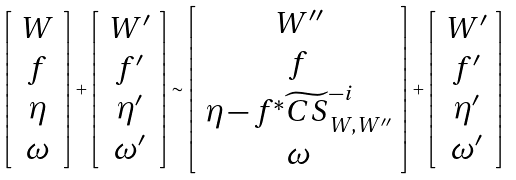Convert formula to latex. <formula><loc_0><loc_0><loc_500><loc_500>\left [ \begin{array} { c } W \\ f \\ \eta \\ \omega \end{array} \right ] + \left [ \begin{array} { c } W ^ { \prime } \\ f ^ { \prime } \\ \eta ^ { \prime } \\ \omega ^ { \prime } \end{array} \right ] \sim \left [ \begin{array} { c } W ^ { \prime \prime } \\ f \\ \eta - f ^ { * } \widetilde { C S } _ { W , W ^ { \prime \prime } } ^ { - i } \\ \omega \end{array} \right ] + \left [ \begin{array} { c } W ^ { \prime } \\ f ^ { \prime } \\ \eta ^ { \prime } \\ \omega ^ { \prime } \end{array} \right ]</formula> 